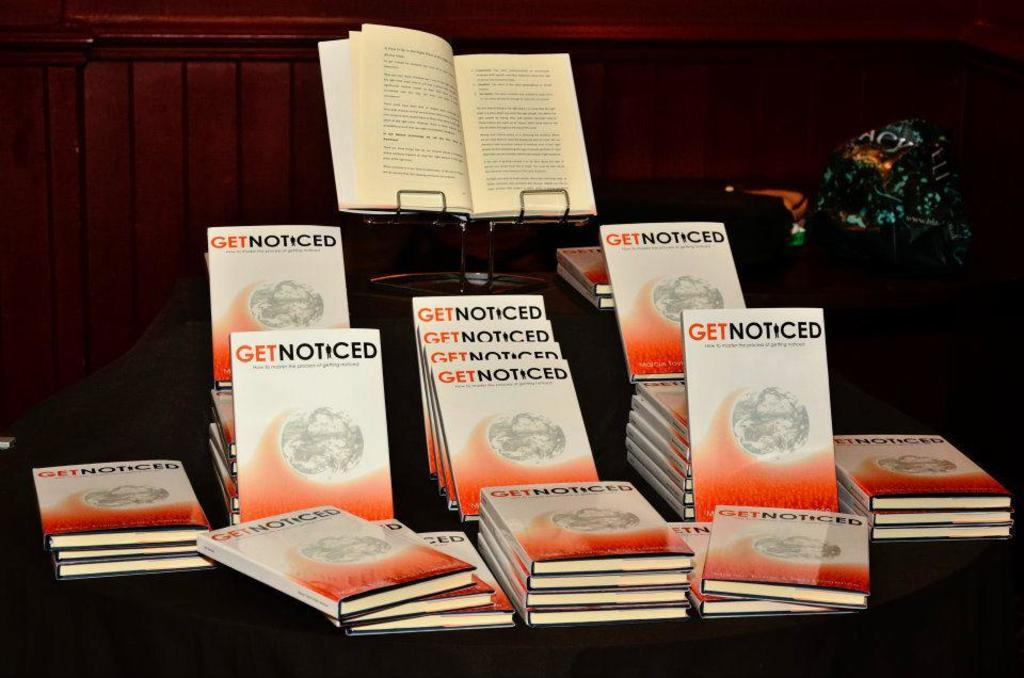<image>
Write a terse but informative summary of the picture. A book called Get Noticed is on display on a dark table 